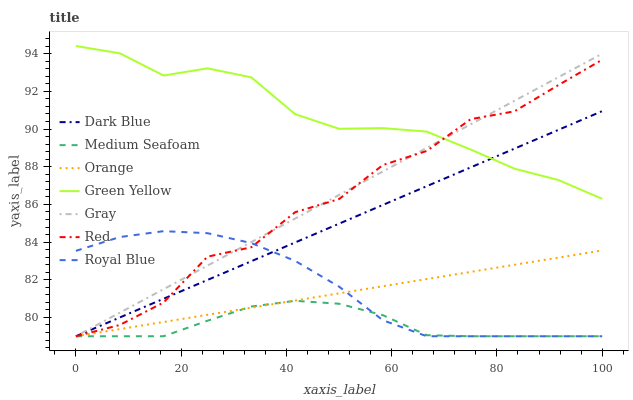Does Royal Blue have the minimum area under the curve?
Answer yes or no. No. Does Royal Blue have the maximum area under the curve?
Answer yes or no. No. Is Royal Blue the smoothest?
Answer yes or no. No. Is Royal Blue the roughest?
Answer yes or no. No. Does Green Yellow have the lowest value?
Answer yes or no. No. Does Royal Blue have the highest value?
Answer yes or no. No. Is Medium Seafoam less than Green Yellow?
Answer yes or no. Yes. Is Green Yellow greater than Orange?
Answer yes or no. Yes. Does Medium Seafoam intersect Green Yellow?
Answer yes or no. No. 